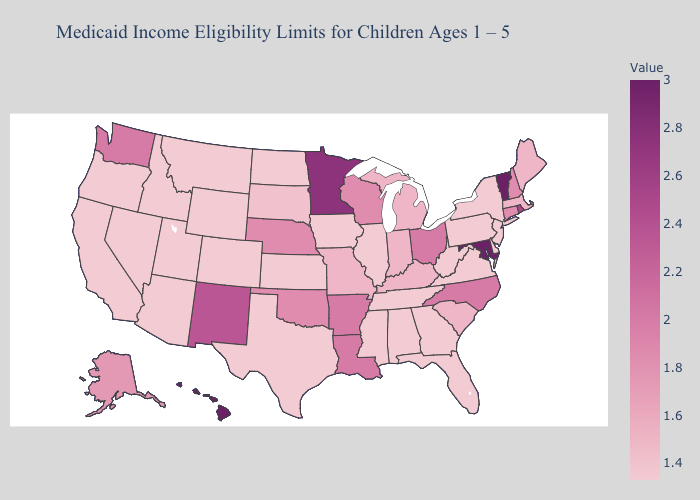Among the states that border Tennessee , does North Carolina have the highest value?
Write a very short answer. Yes. Does South Dakota have the lowest value in the USA?
Quick response, please. No. Which states have the highest value in the USA?
Short answer required. Hawaii, Maryland, Vermont. Which states have the lowest value in the Northeast?
Answer briefly. New Jersey, New York, Pennsylvania. 